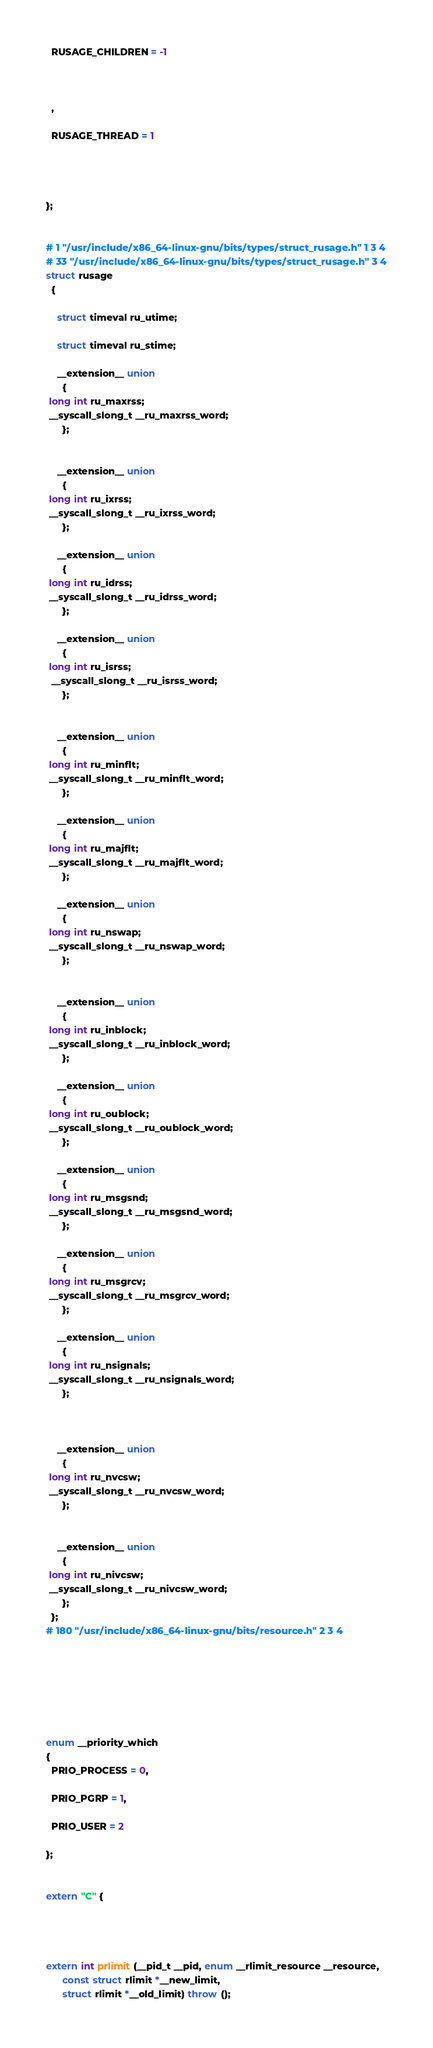Convert code to text. <code><loc_0><loc_0><loc_500><loc_500><_C++_>

  RUSAGE_CHILDREN = -1



  ,

  RUSAGE_THREAD = 1




};


# 1 "/usr/include/x86_64-linux-gnu/bits/types/struct_rusage.h" 1 3 4
# 33 "/usr/include/x86_64-linux-gnu/bits/types/struct_rusage.h" 3 4
struct rusage
  {

    struct timeval ru_utime;

    struct timeval ru_stime;

    __extension__ union
      {
 long int ru_maxrss;
 __syscall_slong_t __ru_maxrss_word;
      };


    __extension__ union
      {
 long int ru_ixrss;
 __syscall_slong_t __ru_ixrss_word;
      };

    __extension__ union
      {
 long int ru_idrss;
 __syscall_slong_t __ru_idrss_word;
      };

    __extension__ union
      {
 long int ru_isrss;
  __syscall_slong_t __ru_isrss_word;
      };


    __extension__ union
      {
 long int ru_minflt;
 __syscall_slong_t __ru_minflt_word;
      };

    __extension__ union
      {
 long int ru_majflt;
 __syscall_slong_t __ru_majflt_word;
      };

    __extension__ union
      {
 long int ru_nswap;
 __syscall_slong_t __ru_nswap_word;
      };


    __extension__ union
      {
 long int ru_inblock;
 __syscall_slong_t __ru_inblock_word;
      };

    __extension__ union
      {
 long int ru_oublock;
 __syscall_slong_t __ru_oublock_word;
      };

    __extension__ union
      {
 long int ru_msgsnd;
 __syscall_slong_t __ru_msgsnd_word;
      };

    __extension__ union
      {
 long int ru_msgrcv;
 __syscall_slong_t __ru_msgrcv_word;
      };

    __extension__ union
      {
 long int ru_nsignals;
 __syscall_slong_t __ru_nsignals_word;
      };



    __extension__ union
      {
 long int ru_nvcsw;
 __syscall_slong_t __ru_nvcsw_word;
      };


    __extension__ union
      {
 long int ru_nivcsw;
 __syscall_slong_t __ru_nivcsw_word;
      };
  };
# 180 "/usr/include/x86_64-linux-gnu/bits/resource.h" 2 3 4







enum __priority_which
{
  PRIO_PROCESS = 0,

  PRIO_PGRP = 1,

  PRIO_USER = 2

};


extern "C" {




extern int prlimit (__pid_t __pid, enum __rlimit_resource __resource,
      const struct rlimit *__new_limit,
      struct rlimit *__old_limit) throw ();</code> 